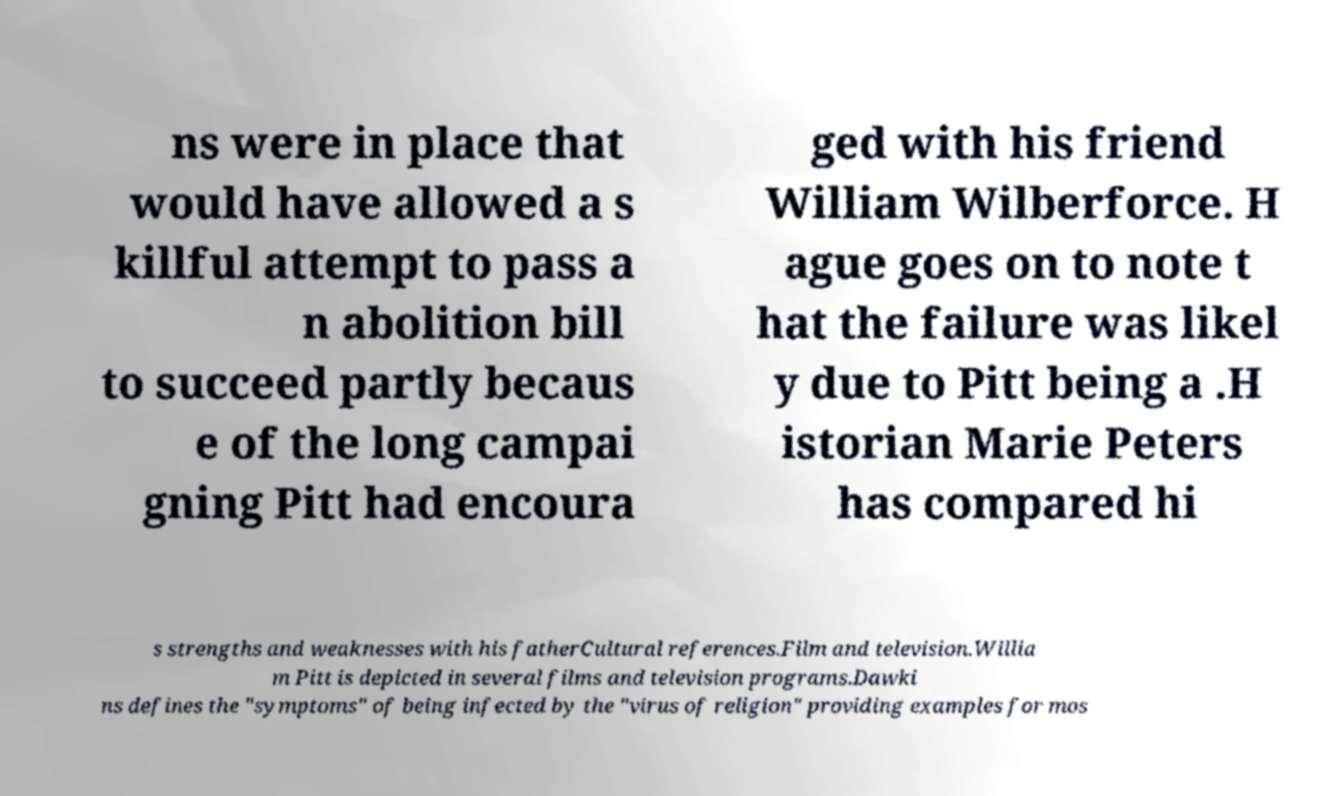Please read and relay the text visible in this image. What does it say? ns were in place that would have allowed a s killful attempt to pass a n abolition bill to succeed partly becaus e of the long campai gning Pitt had encoura ged with his friend William Wilberforce. H ague goes on to note t hat the failure was likel y due to Pitt being a .H istorian Marie Peters has compared hi s strengths and weaknesses with his fatherCultural references.Film and television.Willia m Pitt is depicted in several films and television programs.Dawki ns defines the "symptoms" of being infected by the "virus of religion" providing examples for mos 